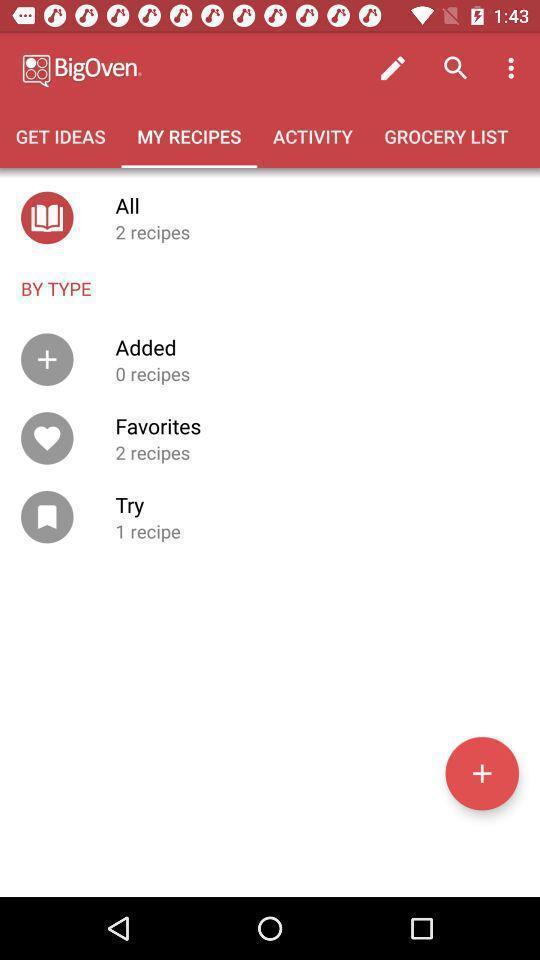Describe the key features of this screenshot. Page showing a variety of recipes. 